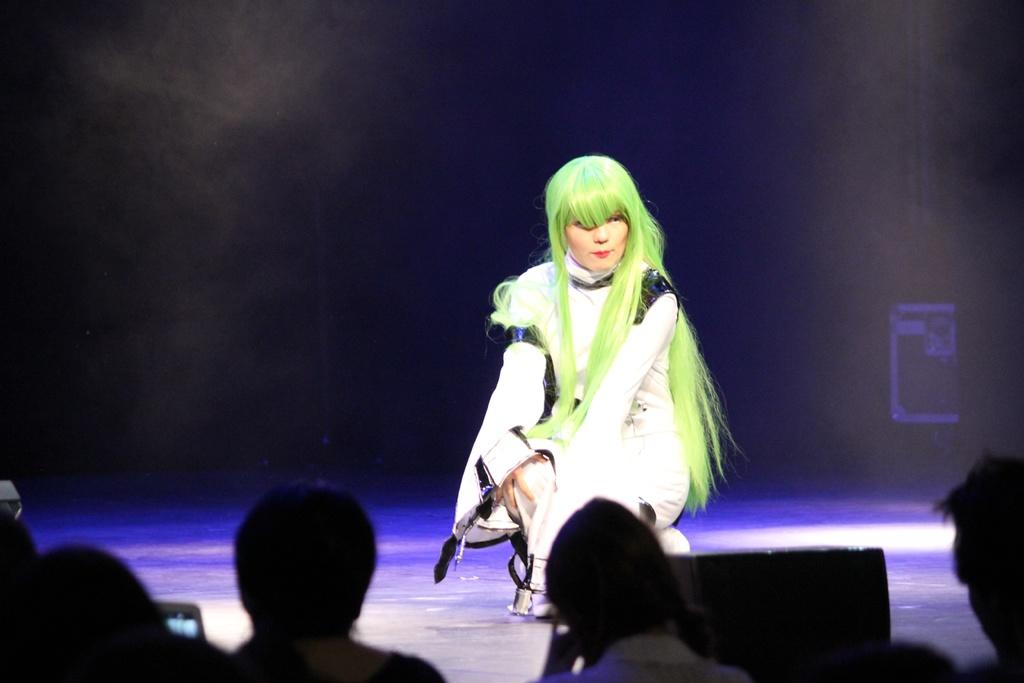Who is the main subject in the image? There is a woman in the image. Where is the woman located? The woman is sitting on a stage. What else can be seen in the image besides the woman? There are spectators in the image. What are the spectators doing? The spectators are watching the woman on the stage. What type of clouds can be seen in the image? There are no clouds present in the image; it features a woman on a stage with spectators watching her. 